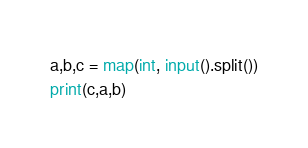<code> <loc_0><loc_0><loc_500><loc_500><_Python_>a,b,c = map(int, input().split())
print(c,a,b)</code> 